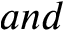Convert formula to latex. <formula><loc_0><loc_0><loc_500><loc_500>a n d</formula> 